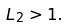Convert formula to latex. <formula><loc_0><loc_0><loc_500><loc_500>L _ { 2 } > 1 .</formula> 